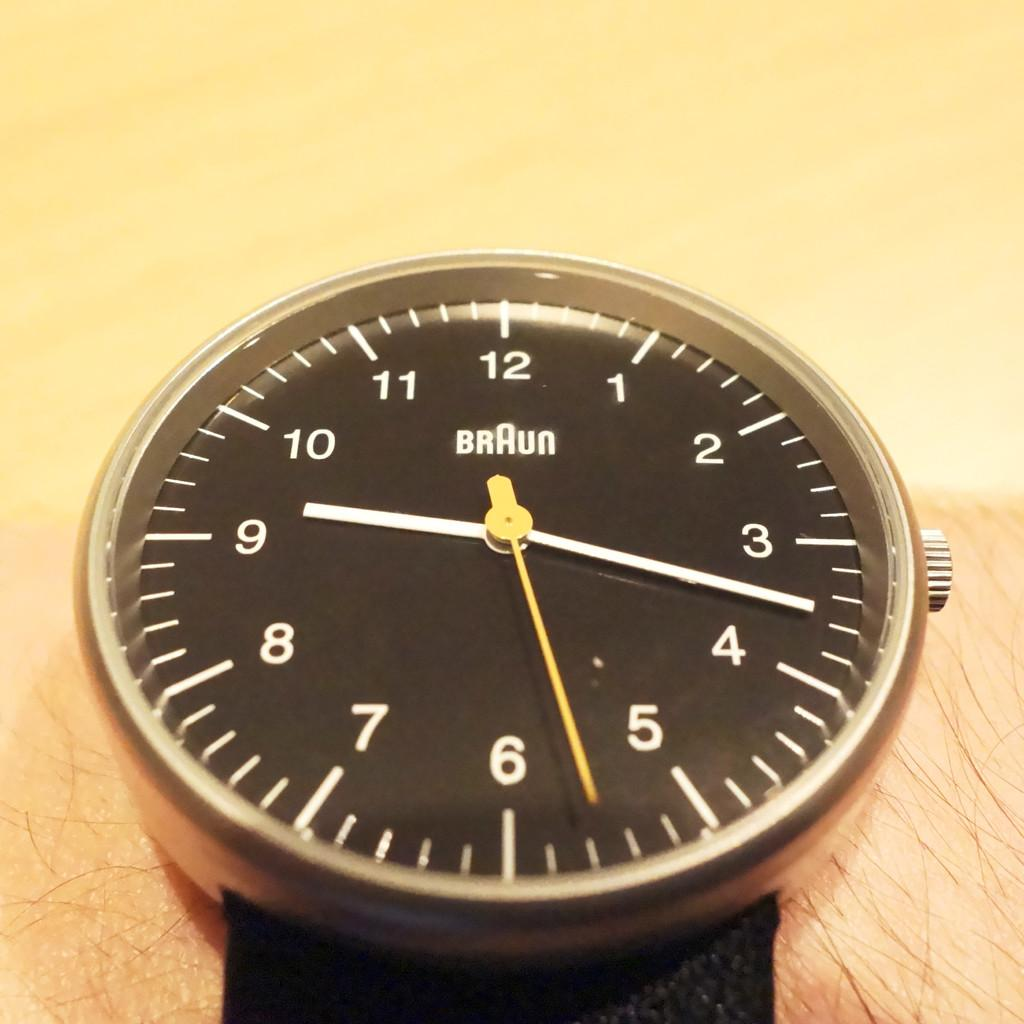<image>
Create a compact narrative representing the image presented. The Braun watch seems as it is very simple and inexpensive. 